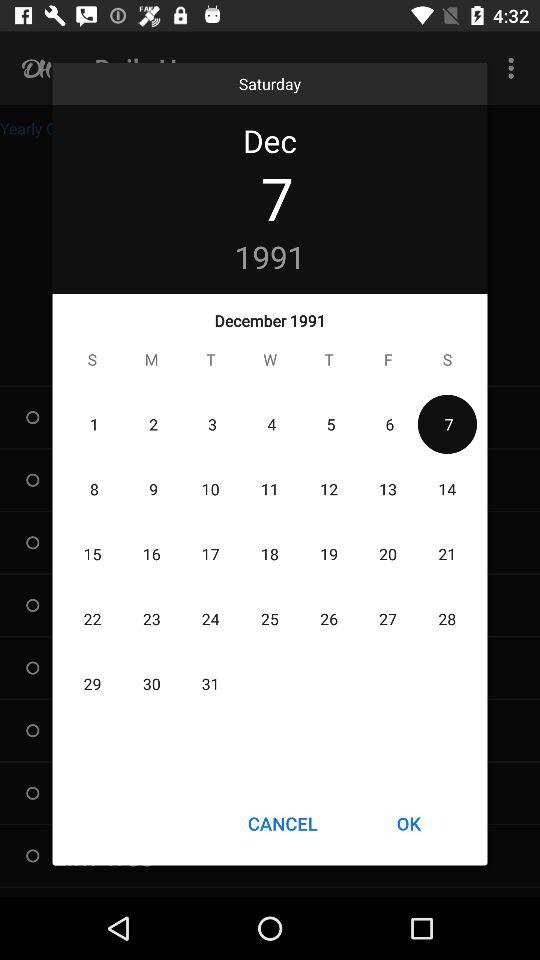What is the mentioned month and year? The mentioned month and year are December 1991, respectively. 